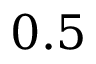Convert formula to latex. <formula><loc_0><loc_0><loc_500><loc_500>0 . 5</formula> 